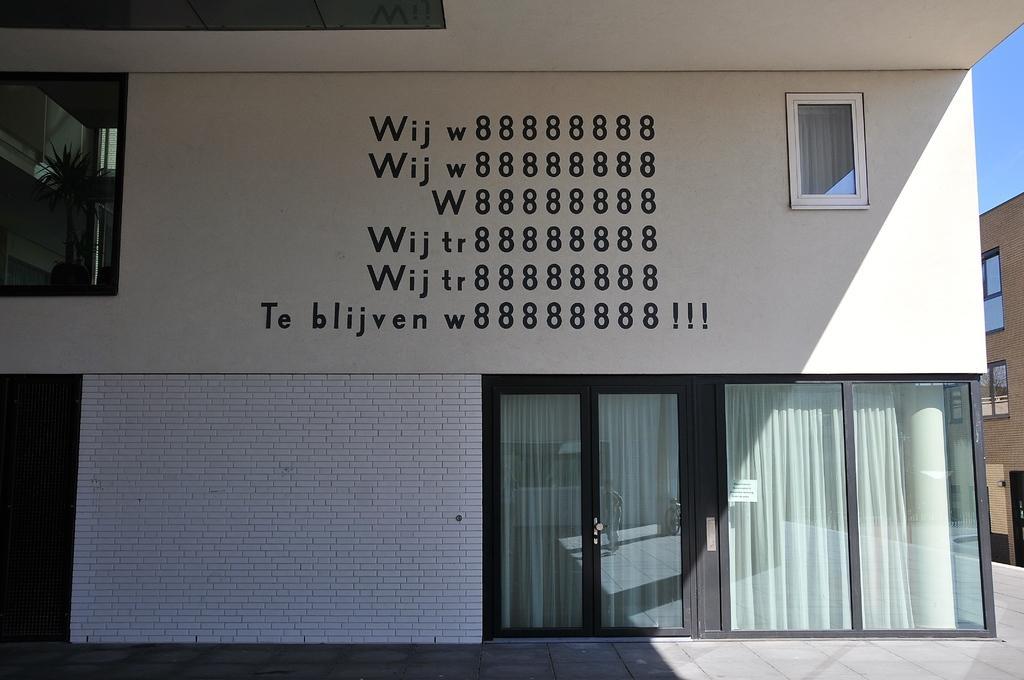How would you summarize this image in a sentence or two? This is the picture of a building. In this image there is a text on the building and there are curtains behind the door and window. On the left side of the image there is a plant behind the window. On the right side of the image there is a building. At the top there is sky. 